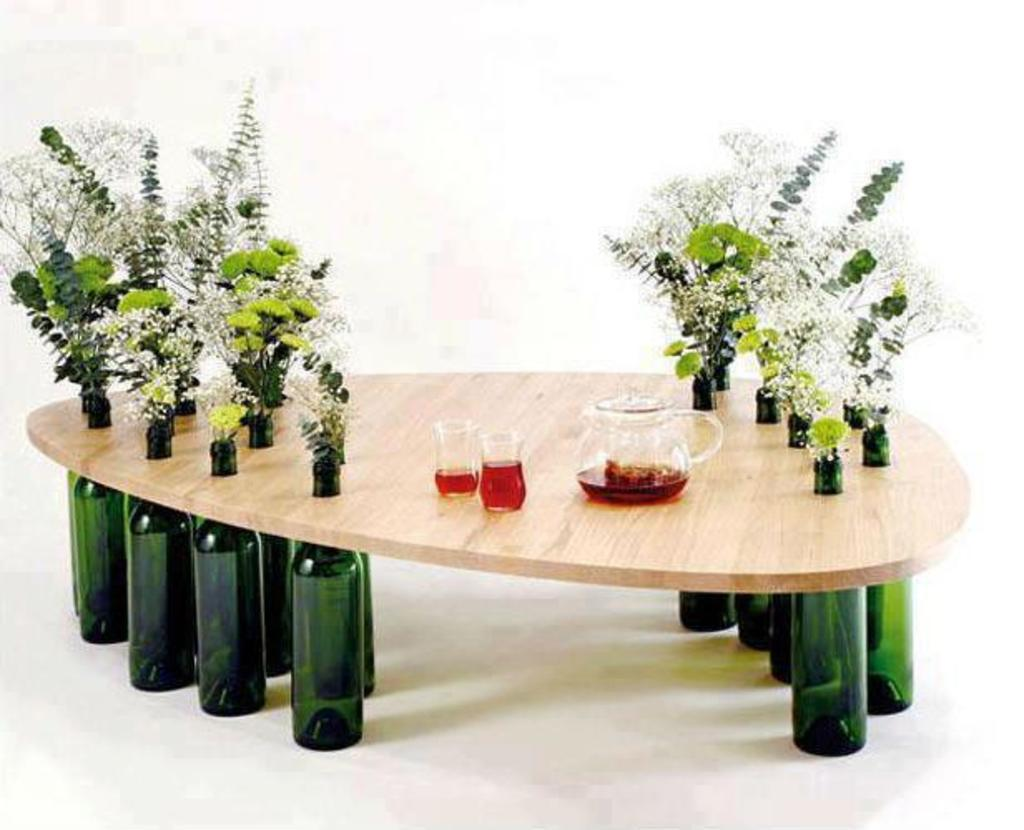What type of beverage containers are in the image? There are coffee cups in the image. What is used to pour coffee into the cups? There is a coffee pot in the image. Where are the coffee cups and coffee pot located? They are on a table in the image. What can be seen on either side of the image? There are plants on either side of the image. What else is present at the bottom of the image? There are bottles at the bottom of the image. How do the tomatoes help increase the coffee's flavor in the image? There are no tomatoes present in the image, and they are not related to the coffee's flavor. 